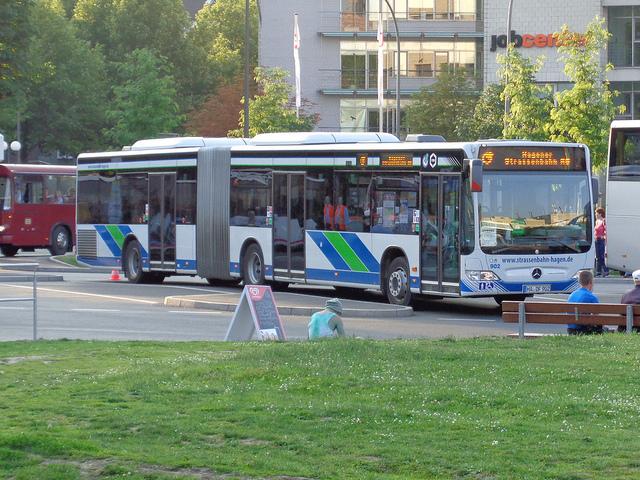What does the bus marquee say on the bus most forward in the photo?
Quick response, please. Downtown riverside. What color is the front?
Keep it brief. White. How many people are sitting on a bench?
Be succinct. 2. Is this an extra long bus?
Concise answer only. Yes. How many people are sitting on the ground?
Give a very brief answer. 1. 